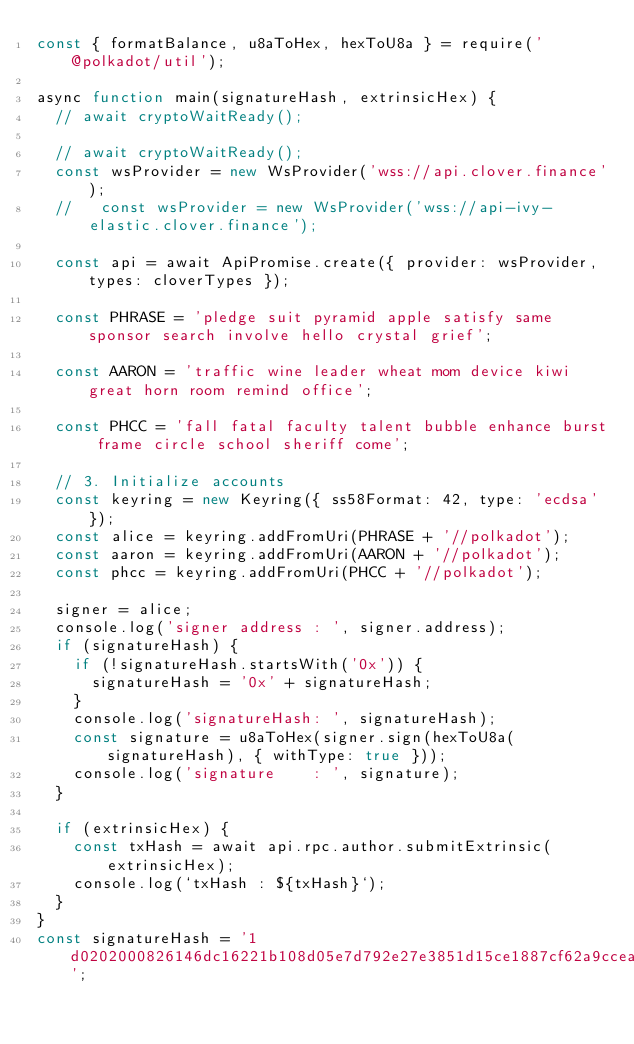Convert code to text. <code><loc_0><loc_0><loc_500><loc_500><_JavaScript_>const { formatBalance, u8aToHex, hexToU8a } = require('@polkadot/util');

async function main(signatureHash, extrinsicHex) {
  // await cryptoWaitReady();

  // await cryptoWaitReady();
  const wsProvider = new WsProvider('wss://api.clover.finance');
  //   const wsProvider = new WsProvider('wss://api-ivy-elastic.clover.finance');

  const api = await ApiPromise.create({ provider: wsProvider, types: cloverTypes });

  const PHRASE = 'pledge suit pyramid apple satisfy same sponsor search involve hello crystal grief';

  const AARON = 'traffic wine leader wheat mom device kiwi great horn room remind office';

  const PHCC = 'fall fatal faculty talent bubble enhance burst frame circle school sheriff come';

  // 3. Initialize accounts
  const keyring = new Keyring({ ss58Format: 42, type: 'ecdsa' });
  const alice = keyring.addFromUri(PHRASE + '//polkadot');
  const aaron = keyring.addFromUri(AARON + '//polkadot');
  const phcc = keyring.addFromUri(PHCC + '//polkadot');

  signer = alice;
  console.log('signer address : ', signer.address);
  if (signatureHash) {
    if (!signatureHash.startsWith('0x')) {
      signatureHash = '0x' + signatureHash;
    }
    console.log('signatureHash: ', signatureHash);
    const signature = u8aToHex(signer.sign(hexToU8a(signatureHash), { withType: true }));
    console.log('signature    : ', signature);
  }

  if (extrinsicHex) {
    const txHash = await api.rpc.author.submitExtrinsic(extrinsicHex);
    console.log(`txHash : ${txHash}`);
  }
}
const signatureHash = '1d0202000826146dc16221b108d05e7d792e27e3851d15ce1887cf62a9ccea554e43426a53821540197c5fac46ab60c747b3d54f90ed99b216cfc886c789b988ea68ee0aaa00bf13d36031407d5ede1415e0e93e16606fffa0f46b70481aded73627b93465c400a025260000000000ac001100000001000000dd97e5ad3f0015f2dc45c9467b0fd36a2b7f4b9a7bc65e8111d49d6cf19c8927dd97e5ad3f0015f2dc45c9467b0fd36a2b7f4b9a7bc65e8111d49d6cf19c8927';</code> 